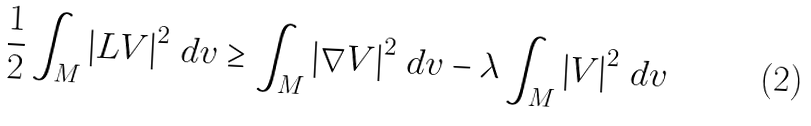Convert formula to latex. <formula><loc_0><loc_0><loc_500><loc_500>\frac { 1 } { 2 } \int _ { M } \left | L V \right | ^ { 2 } \, d v \geq \int _ { M } \left | \nabla V \right | ^ { 2 } \, d v - \lambda \int _ { M } \left | V \right | ^ { 2 } \, d v</formula> 